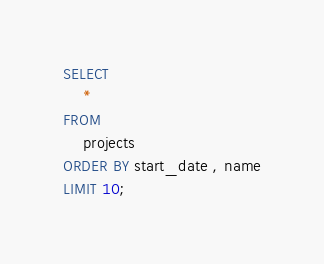Convert code to text. <code><loc_0><loc_0><loc_500><loc_500><_SQL_>SELECT 
    *
FROM
    projects
ORDER BY start_date , name
LIMIT 10;</code> 